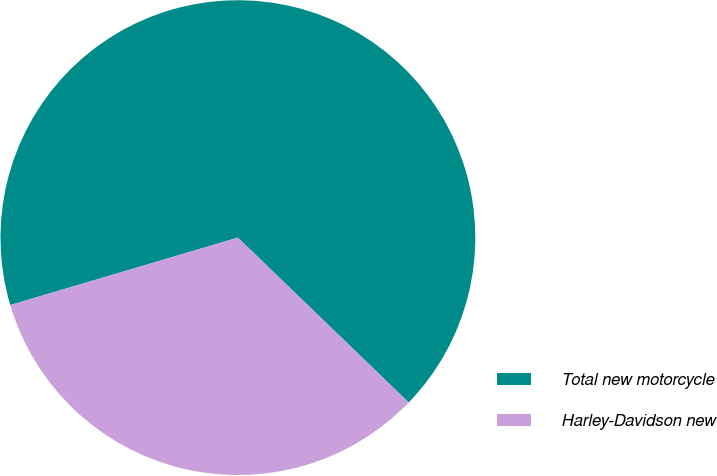<chart> <loc_0><loc_0><loc_500><loc_500><pie_chart><fcel>Total new motorcycle<fcel>Harley-Davidson new<nl><fcel>66.8%<fcel>33.2%<nl></chart> 